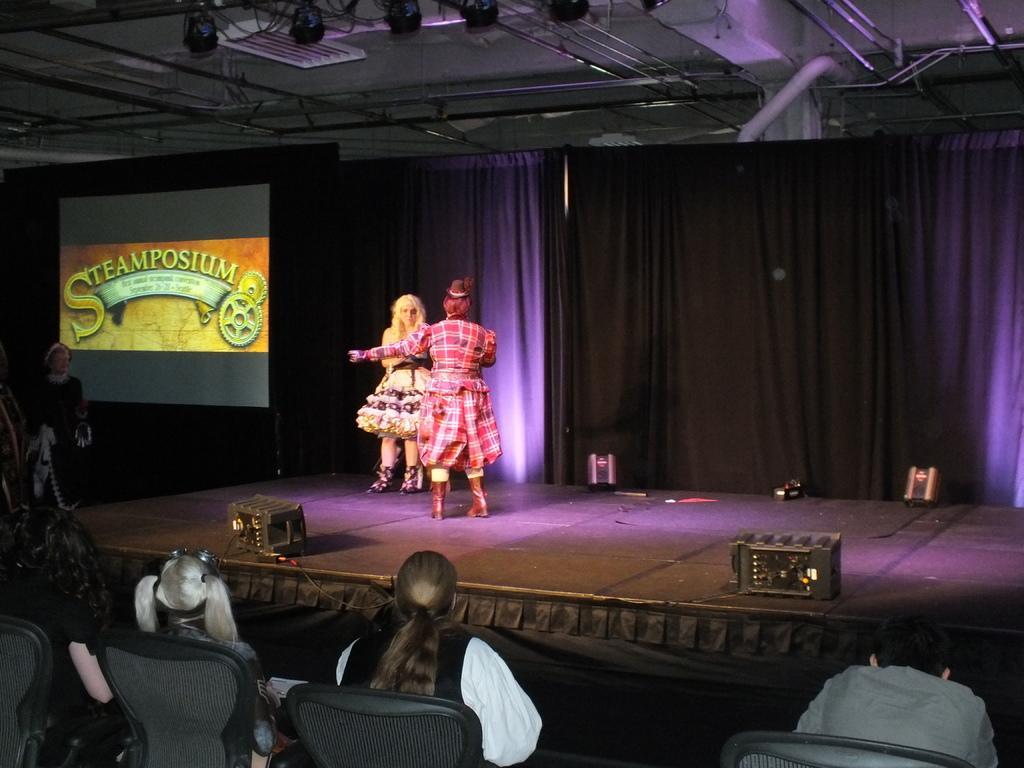Describe this image in one or two sentences. In this image, there are a few people. Among them, some people are sitting on chairs and some people are on the stage. We can also see some objects on the stage. We can see a screen and some curtains. We can also see some objects attached to the roof. 